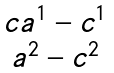Convert formula to latex. <formula><loc_0><loc_0><loc_500><loc_500>\begin{matrix} { c } a ^ { 1 } - c ^ { 1 } \\ a ^ { 2 } - c ^ { 2 } \end{matrix}</formula> 